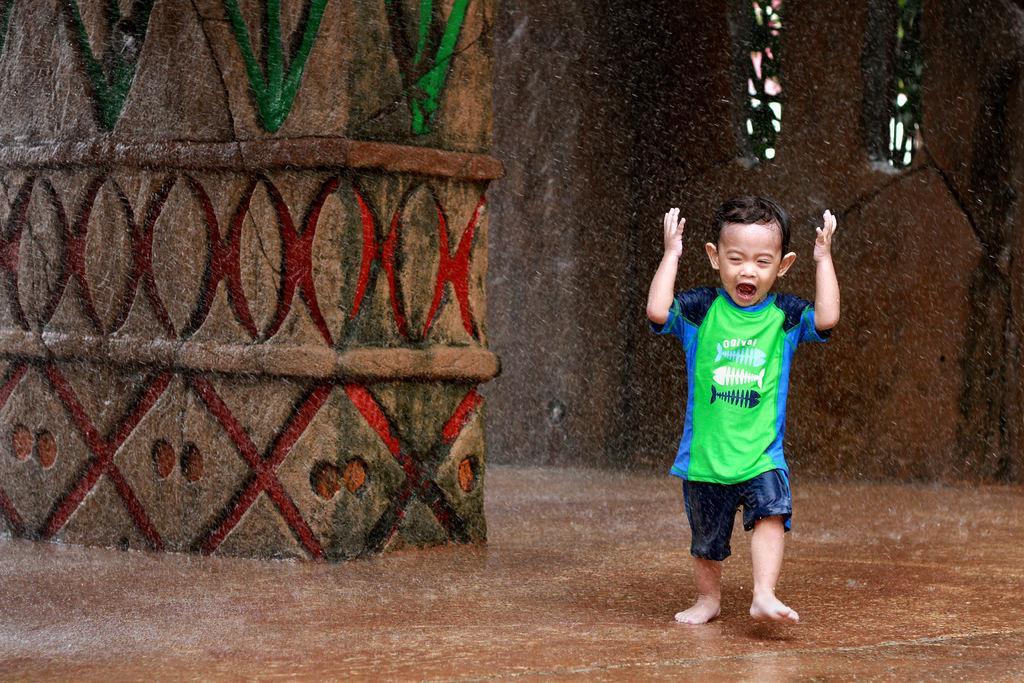Please provide a concise description of this image. In this image I can see the person standing on the brown color surface. The person is wearing the green, blue and navy blue color dress. In the back I can see the wall which is in brown color. 